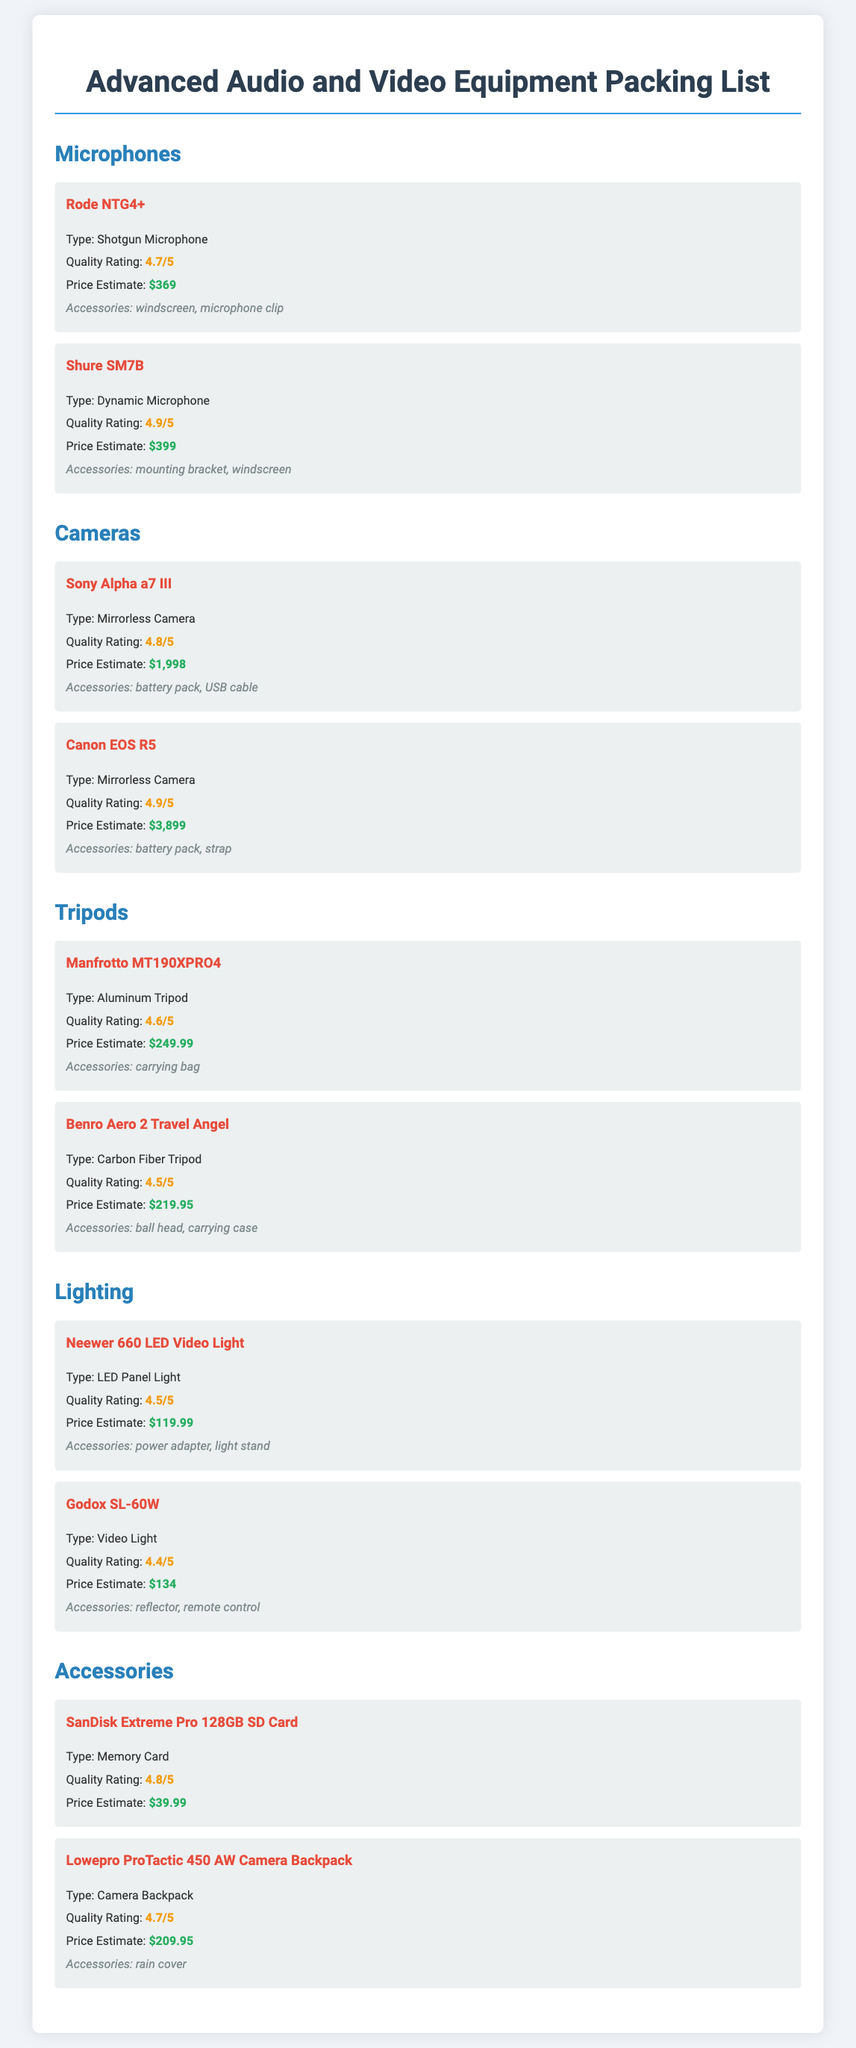What is the quality rating of the Rode NTG4+? The quality rating for the Rode NTG4+ is explicitly stated in the document as 4.7/5.
Answer: 4.7/5 What type of camera is the Canon EOS R5? The document specifies that the Canon EOS R5 is a mirrorless camera.
Answer: Mirrorless Camera What is the price estimate for the Shure SM7B? The price estimate for the Shure SM7B is clearly noted as $399.
Answer: $399 Which tripod has a higher quality rating: Manfrotto MT190XPRO4 or Benro Aero 2 Travel Angel? Comparing the quality ratings shows that the Manfrotto MT190XPRO4 has a rating of 4.6/5 while the Benro Aero 2 Travel Angel has a rating of 4.5/5, indicating the Manfrotto is higher.
Answer: Manfrotto MT190XPRO4 What accessories are included with the SanDisk Extreme Pro 128GB SD Card? The document lists no accessories for the SanDisk Extreme Pro 128GB SD Card, indicating it comes alone.
Answer: None What is the total price estimate for the Neewer 660 LED Video Light and Godox SL-60W? The document states the Neewer 660 LED Video Light costs $119.99 and the Godox SL-60W costs $134; adding these gives a total of $253.99.
Answer: $253.99 What type of lighting equipment is the Godox SL-60W? The Godox SL-60W is categorized in the document as a video light.
Answer: Video Light Which item has the highest quality rating? The Shure SM7B holds the highest quality rating in the document at 4.9/5.
Answer: 4.9/5 